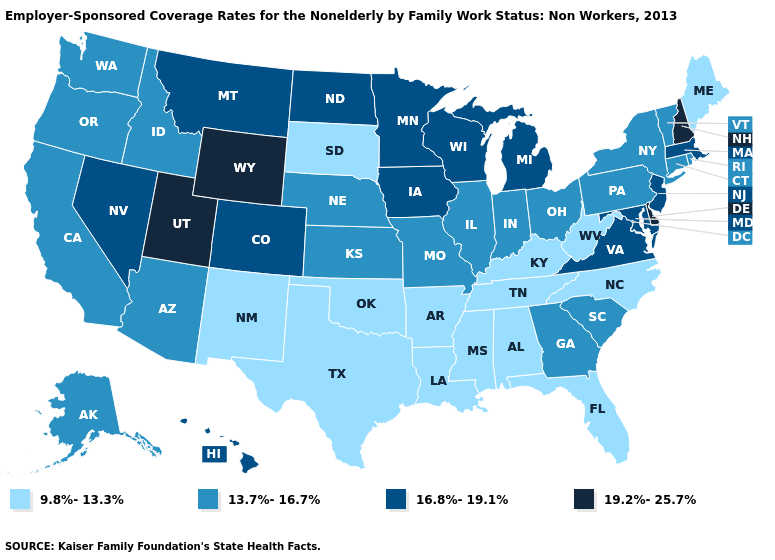Does Virginia have a lower value than Utah?
Keep it brief. Yes. Does Nevada have a lower value than New York?
Answer briefly. No. What is the value of Arizona?
Answer briefly. 13.7%-16.7%. Which states have the highest value in the USA?
Be succinct. Delaware, New Hampshire, Utah, Wyoming. Does Alabama have the lowest value in the USA?
Concise answer only. Yes. Does Massachusetts have the same value as New Mexico?
Concise answer only. No. Does the map have missing data?
Be succinct. No. Among the states that border Rhode Island , which have the lowest value?
Answer briefly. Connecticut. Does the first symbol in the legend represent the smallest category?
Concise answer only. Yes. What is the value of Virginia?
Concise answer only. 16.8%-19.1%. What is the value of New Mexico?
Short answer required. 9.8%-13.3%. Does Missouri have the lowest value in the MidWest?
Write a very short answer. No. Name the states that have a value in the range 13.7%-16.7%?
Answer briefly. Alaska, Arizona, California, Connecticut, Georgia, Idaho, Illinois, Indiana, Kansas, Missouri, Nebraska, New York, Ohio, Oregon, Pennsylvania, Rhode Island, South Carolina, Vermont, Washington. What is the value of Virginia?
Quick response, please. 16.8%-19.1%. Does Vermont have the highest value in the Northeast?
Be succinct. No. 